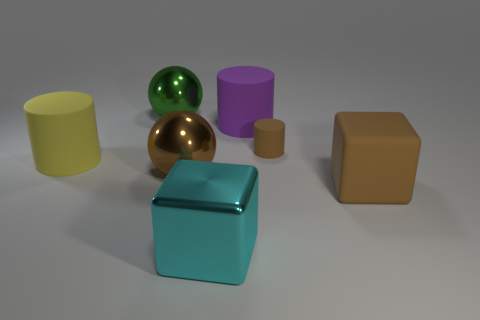Subtract all big matte cylinders. How many cylinders are left? 1 Subtract 1 cylinders. How many cylinders are left? 2 Add 2 green shiny spheres. How many objects exist? 9 Subtract 0 red cubes. How many objects are left? 7 Subtract all cylinders. How many objects are left? 4 Subtract all green cylinders. Subtract all yellow cubes. How many cylinders are left? 3 Subtract all cyan cylinders. How many gray balls are left? 0 Subtract all tiny brown cylinders. Subtract all large purple objects. How many objects are left? 5 Add 6 tiny cylinders. How many tiny cylinders are left? 7 Add 5 big yellow matte balls. How many big yellow matte balls exist? 5 